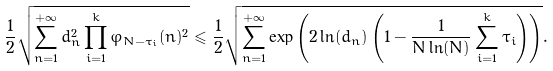<formula> <loc_0><loc_0><loc_500><loc_500>\frac { 1 } { 2 } \sqrt { \sum _ { n = 1 } ^ { + \infty } d _ { n } ^ { 2 } \prod _ { i = 1 } ^ { k } \varphi _ { N - \tau _ { i } } ( n ) ^ { 2 } } \leqslant \frac { 1 } { 2 } \sqrt { \sum _ { n = 1 } ^ { + \infty } \exp \left ( 2 \ln ( d _ { n } ) \left ( 1 - \frac { 1 } { N \ln ( N ) } \sum _ { i = 1 } ^ { k } \tau _ { i } \right ) \right ) } .</formula> 